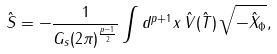Convert formula to latex. <formula><loc_0><loc_0><loc_500><loc_500>\hat { S } = - \frac { 1 } { G _ { s } ( 2 \pi ) ^ { \frac { p - 1 } { 2 } } } \int d ^ { p + 1 } x \, \hat { V } ( \hat { T } ) \, \sqrt { - { \hat { X } } _ { \Phi } } ,</formula> 